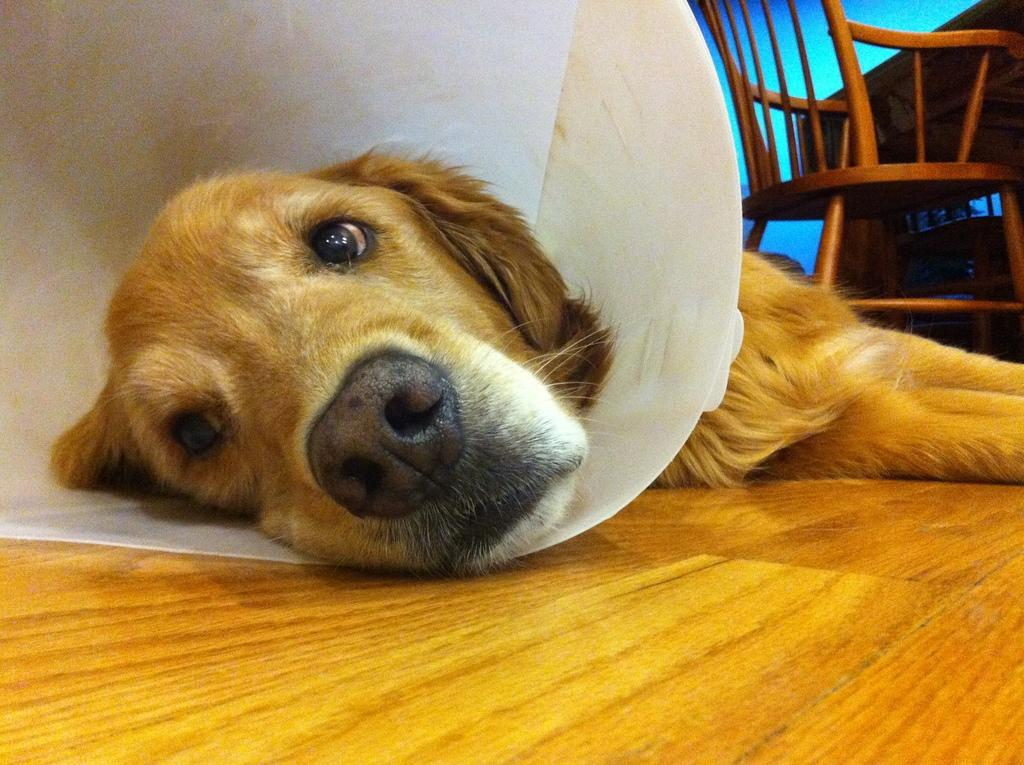What animal can be seen in the image? There is a dog in the image. What is the dog doing in the image? The dog is lying on the floor. What furniture is visible in the background of the image? There is a chair in the background of the image. What type of vegetable is the dog holding in its paw in the image? There is no vegetable present in the image, and the dog is not holding anything in its paw. 